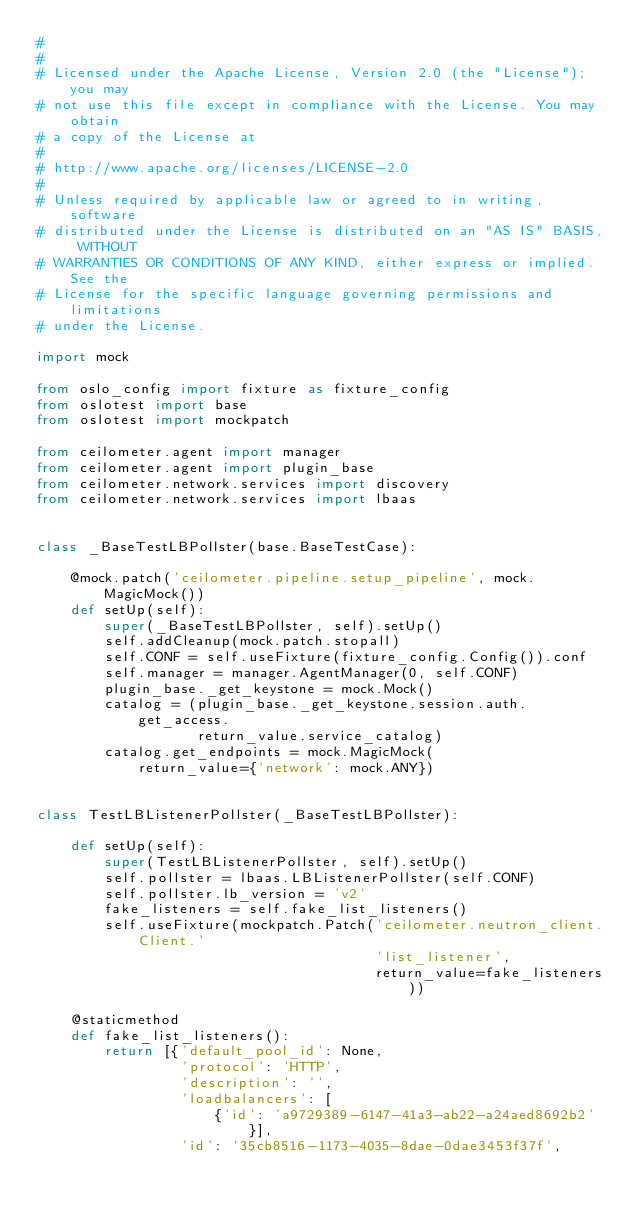Convert code to text. <code><loc_0><loc_0><loc_500><loc_500><_Python_>#
#
# Licensed under the Apache License, Version 2.0 (the "License"); you may
# not use this file except in compliance with the License. You may obtain
# a copy of the License at
#
# http://www.apache.org/licenses/LICENSE-2.0
#
# Unless required by applicable law or agreed to in writing, software
# distributed under the License is distributed on an "AS IS" BASIS, WITHOUT
# WARRANTIES OR CONDITIONS OF ANY KIND, either express or implied. See the
# License for the specific language governing permissions and limitations
# under the License.

import mock

from oslo_config import fixture as fixture_config
from oslotest import base
from oslotest import mockpatch

from ceilometer.agent import manager
from ceilometer.agent import plugin_base
from ceilometer.network.services import discovery
from ceilometer.network.services import lbaas


class _BaseTestLBPollster(base.BaseTestCase):

    @mock.patch('ceilometer.pipeline.setup_pipeline', mock.MagicMock())
    def setUp(self):
        super(_BaseTestLBPollster, self).setUp()
        self.addCleanup(mock.patch.stopall)
        self.CONF = self.useFixture(fixture_config.Config()).conf
        self.manager = manager.AgentManager(0, self.CONF)
        plugin_base._get_keystone = mock.Mock()
        catalog = (plugin_base._get_keystone.session.auth.get_access.
                   return_value.service_catalog)
        catalog.get_endpoints = mock.MagicMock(
            return_value={'network': mock.ANY})


class TestLBListenerPollster(_BaseTestLBPollster):

    def setUp(self):
        super(TestLBListenerPollster, self).setUp()
        self.pollster = lbaas.LBListenerPollster(self.CONF)
        self.pollster.lb_version = 'v2'
        fake_listeners = self.fake_list_listeners()
        self.useFixture(mockpatch.Patch('ceilometer.neutron_client.Client.'
                                        'list_listener',
                                        return_value=fake_listeners))

    @staticmethod
    def fake_list_listeners():
        return [{'default_pool_id': None,
                 'protocol': 'HTTP',
                 'description': '',
                 'loadbalancers': [
                     {'id': 'a9729389-6147-41a3-ab22-a24aed8692b2'}],
                 'id': '35cb8516-1173-4035-8dae-0dae3453f37f',</code> 